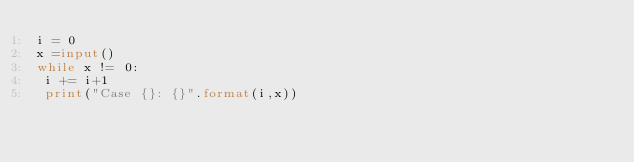Convert code to text. <code><loc_0><loc_0><loc_500><loc_500><_Python_>i = 0
x =input()
while x != 0:
 i += i+1
 print("Case {}: {}".format(i,x))

</code> 